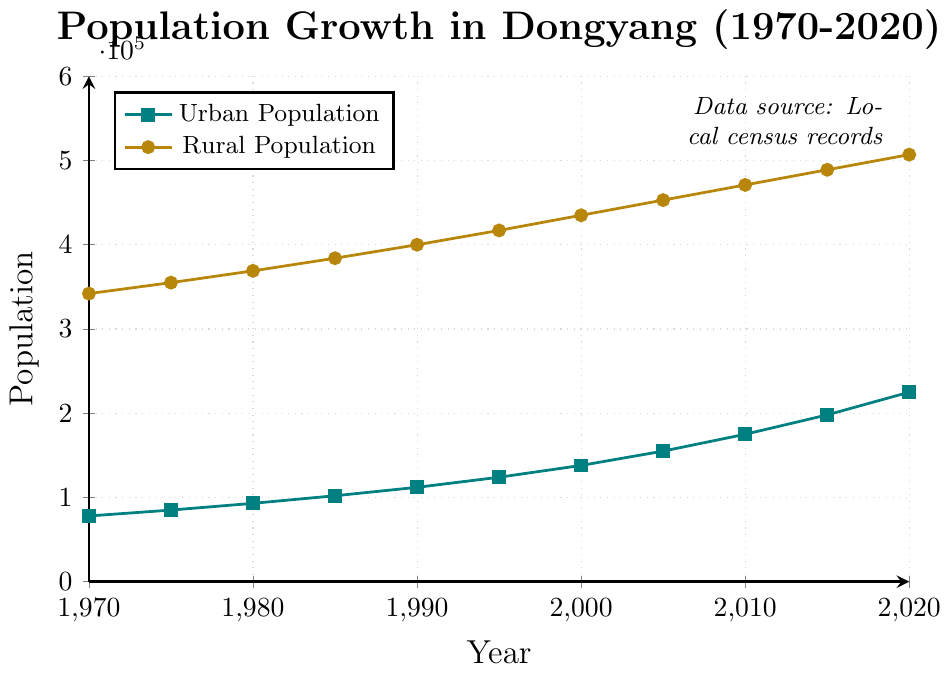What is the population growth trend in urban areas from 1970 to 2020? From 1970 to 2020, the urban population consistently increased each year. The plot shows a steady upward trend in the urban population line, indicating growth in urban areas over these 50 years.
Answer: Consistent increase From which year did the urban population start to exceed 200,000? Find the point where the urban population line crosses the 200,000 mark. This happens between 2015 and 2020. By looking closely, the urban population was 198,000 in 2015 and exceeded 200,000 by 2020.
Answer: 2020 Which population, urban or rural, has a higher growth rate from 1970 to 2020? Calculate the growth for both populations: Urban growth = 225,000 - 78,000 = 147,000; Rural growth = 507,000 - 342,000 = 165,000. The rural population has a higher absolute growth.
Answer: Rural By how much did the rural population increase from 1980 to 2000? Subtract the rural population in 1980 from that in 2000: 435,000 (2000) - 369,000 (1980) = 66,000.
Answer: 66,000 What is the difference between urban and rural populations in 2020? Subtract the urban population from the rural population for 2020: 507,000 - 225,000 = 282,000.
Answer: 282,000 Identify the period with the steepest growth in urban population. Look for the steepest section of the urban population line. The largest increase between two consecutive points is between 2015 and 2020, from 198,000 to 225,000, an increase of 27,000.
Answer: 2015-2020 What is the average rural population from 1970 to 2020? Sum all rural populations and divide by the number of years: (342,000 + 355,000 + 369,000 + 384,000 + 400,000 + 417,000 + 435,000 + 453,000 + 471,000 + 489,000 + 507,000) / 11 = 419,000.
Answer: 419,000 Compare the urban population in 1980 with the rural population in 1990. Read the values from the graph: Urban population in 1980 is 93,000, and rural population in 1990 is 400,000. The rural population in 1990 is considerably higher than the urban population in 1980.
Answer: Rural in 1990 is higher What are the colors used to differentiate urban and rural populations? The plot uses distinct colors for the lines. The urban population is indicated with a teal color, and the rural population with a golden color.
Answer: Teal and golden How much did the combined population (urban + rural) of Dongyang increase from 1970 to 2020? Sum the initial and final combined populations: (78,000 + 342,000) = 420,000 in 1970 and (225,000 + 507,000) = 732,000 in 2020. The increase is 732,000 - 420,000 = 312,000.
Answer: 312,000 